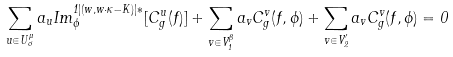Convert formula to latex. <formula><loc_0><loc_0><loc_500><loc_500>\sum _ { u \in U ^ { \mu } _ { \sigma } } a _ { u } I m ^ { 1 | ( w , w \cdot \kappa - K ) | * } _ { \phi } [ C ^ { u } _ { g } ( f ) ] + \sum _ { v \in V ^ { \beta } _ { 1 } } a _ { v } C ^ { v } _ { g } ( f , \phi ) + \sum _ { v \in V ^ { \prime } _ { 2 } } a _ { v } C ^ { v } _ { g } ( f , \phi ) = 0</formula> 